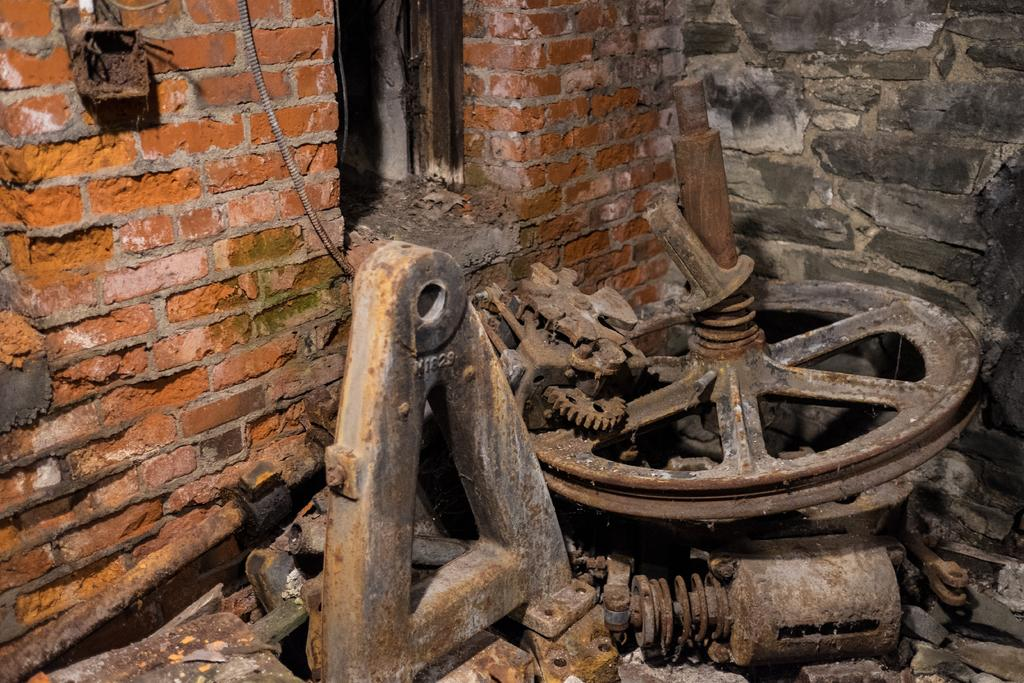What type of structure is visible in the image? There is a brick wall in the image. What mechanical object can be seen in the image? There is a wheel in the image. What type of material is used for the objects in the image? There are iron objects in the image. What time is displayed on the hour in the image? There is no clock or hour display present in the image. What type of brass object can be seen in the image? There is no brass object present in the image. 